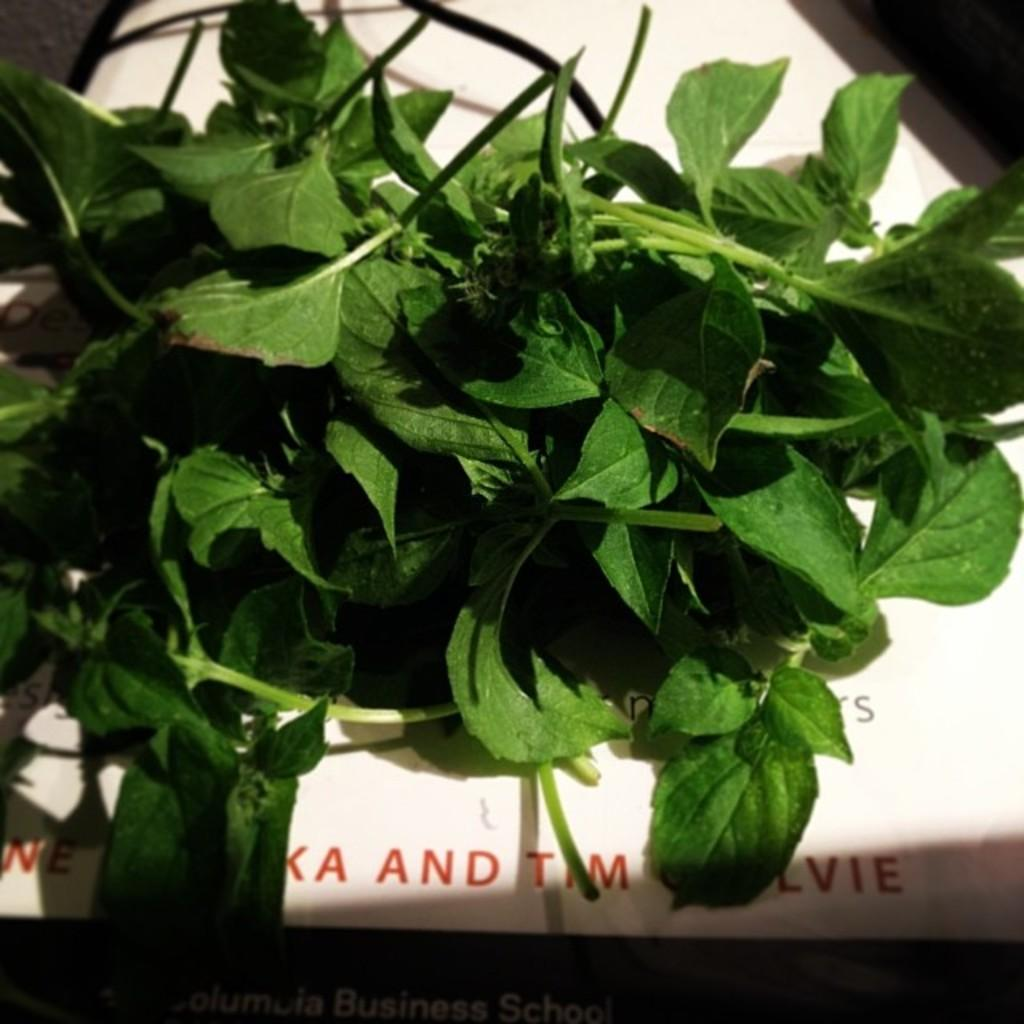What type of plant material is present in the image? There are green leaves with stems in the image. What is the color of the object on which the leaves and stems are placed? The leaves and stems are placed on a white object. Is there any text visible in the image? Yes, there is text visible at the bottom of the image. What type of crime is being committed in the image? There is no crime present in the image; it features green leaves with stems placed on a white object and text at the bottom. What is the reaction of the leaves to the presence of clouds in the image? There are no clouds present in the image, so the leaves' reaction cannot be determined. 